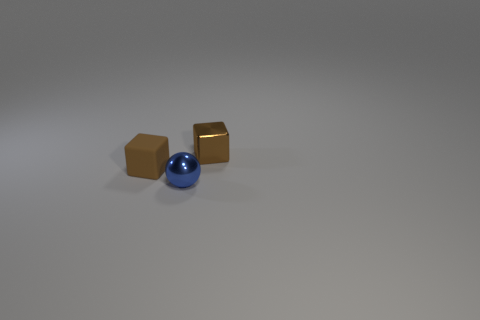How many small objects are either blue shiny things or yellow rubber balls?
Your answer should be very brief. 1. Is the size of the matte cube the same as the shiny object behind the brown matte cube?
Ensure brevity in your answer.  Yes. Is there anything else that has the same shape as the matte thing?
Your response must be concise. Yes. What number of tiny brown matte cubes are there?
Offer a very short reply. 1. How many brown objects are either cubes or tiny matte cubes?
Make the answer very short. 2. Does the tiny brown object that is behind the tiny brown matte cube have the same material as the tiny blue ball?
Make the answer very short. Yes. What is the ball made of?
Ensure brevity in your answer.  Metal. What is the size of the shiny object on the right side of the small sphere?
Offer a terse response. Small. There is a brown object that is left of the metallic ball; how many blue objects are behind it?
Make the answer very short. 0. There is a thing behind the matte object; is it the same shape as the small thing that is on the left side of the blue metal thing?
Ensure brevity in your answer.  Yes. 